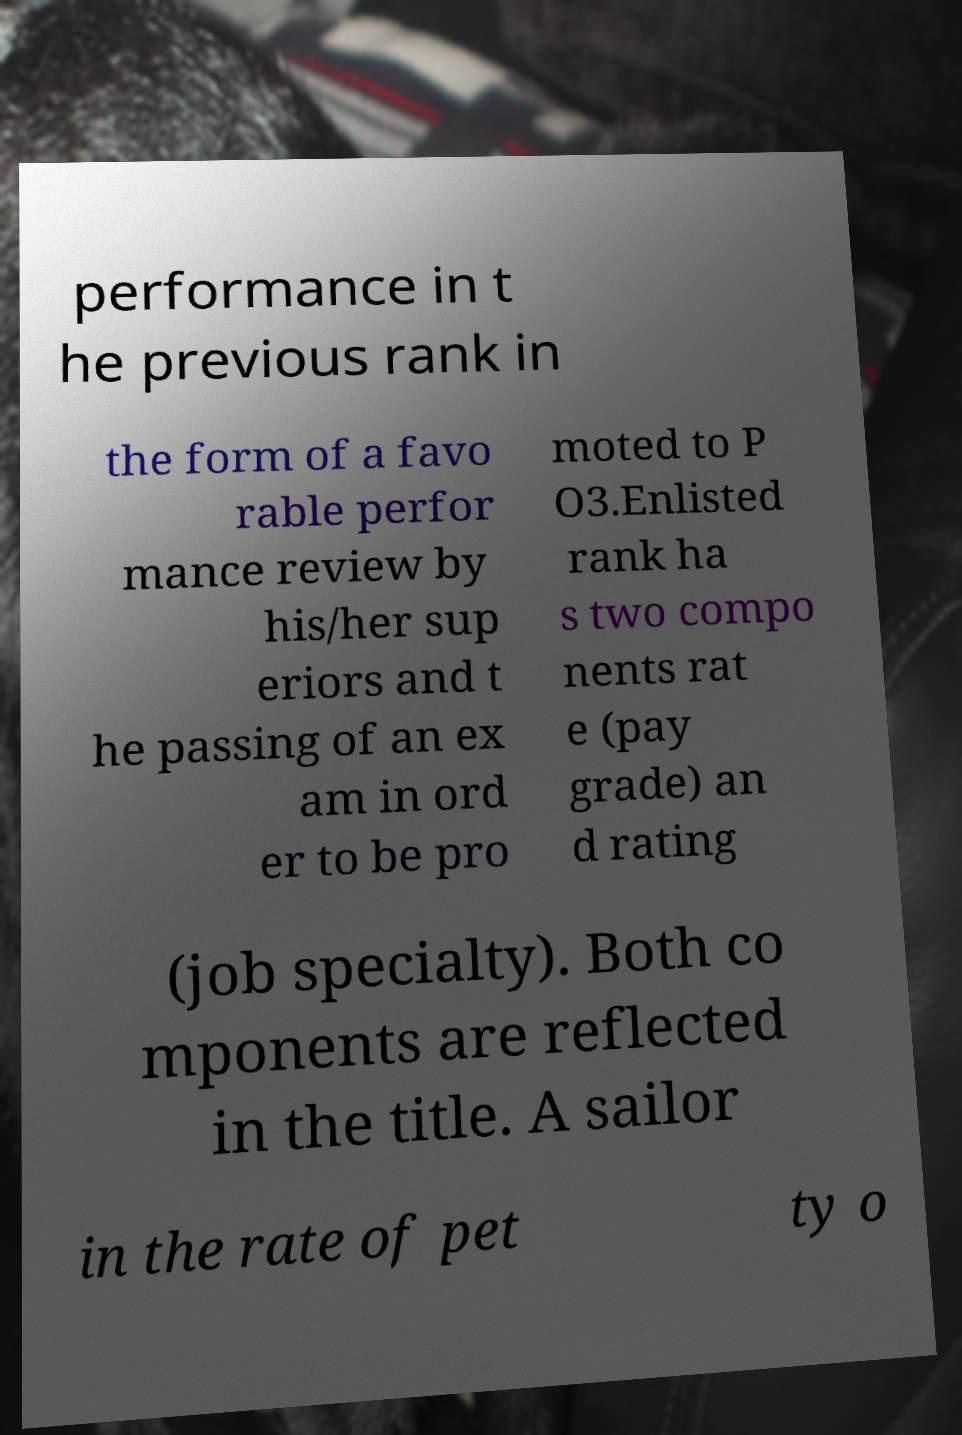There's text embedded in this image that I need extracted. Can you transcribe it verbatim? performance in t he previous rank in the form of a favo rable perfor mance review by his/her sup eriors and t he passing of an ex am in ord er to be pro moted to P O3.Enlisted rank ha s two compo nents rat e (pay grade) an d rating (job specialty). Both co mponents are reflected in the title. A sailor in the rate of pet ty o 